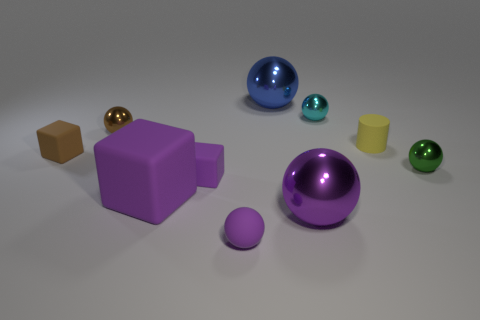Is there anything else that is the same shape as the yellow rubber object?
Offer a terse response. No. There is another sphere that is the same color as the rubber sphere; what material is it?
Ensure brevity in your answer.  Metal. Does the tiny yellow cylinder have the same material as the brown sphere?
Ensure brevity in your answer.  No. There is a metal ball that is both left of the tiny cyan metal sphere and right of the blue shiny sphere; what is its size?
Offer a very short reply. Large. What is the shape of the tiny cyan object?
Offer a very short reply. Sphere. How many things are large brown matte balls or tiny green things right of the large purple metallic object?
Keep it short and to the point. 1. Is the color of the large metal thing that is in front of the small cyan shiny sphere the same as the large block?
Your answer should be compact. Yes. There is a small ball that is in front of the small cyan metal thing and right of the matte ball; what is its color?
Your answer should be very brief. Green. What material is the brown object left of the small brown ball?
Give a very brief answer. Rubber. The cyan ball is what size?
Keep it short and to the point. Small. 